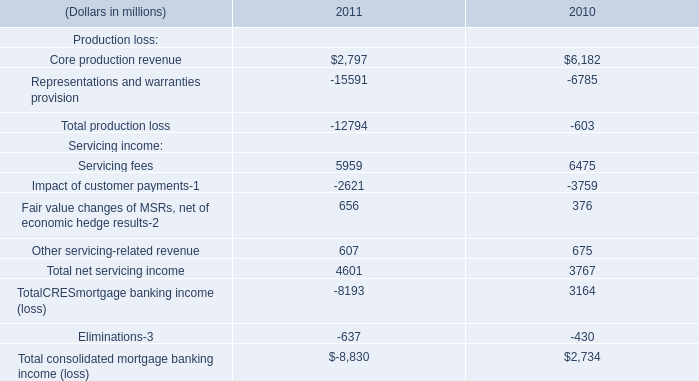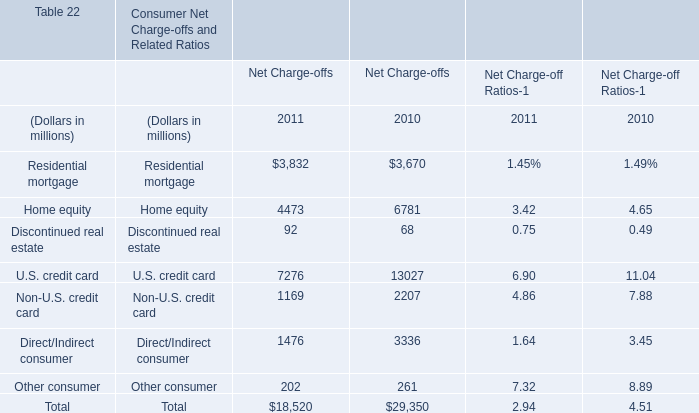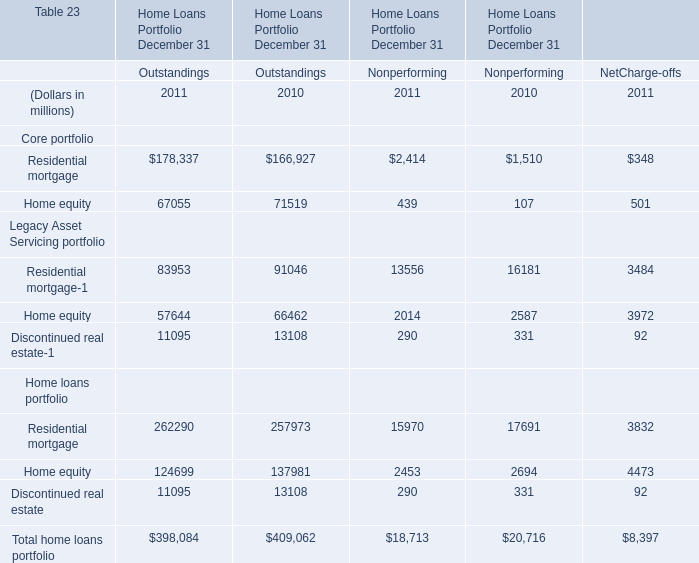When is Residential mortgage the largest for Net Charge-offs? 
Answer: 2011. 